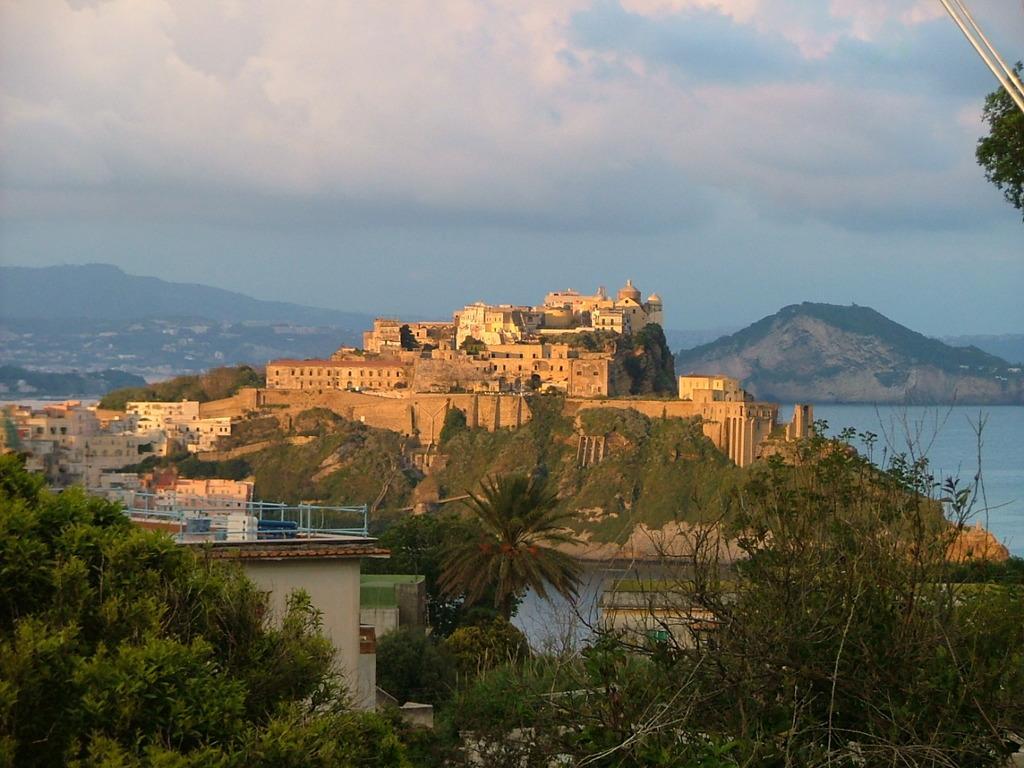Could you give a brief overview of what you see in this image? In this image I can see number of trees and number of buildings in the front. In the background I can see water, mountains, clouds and the sky. I can also see few silver colour things and a tree on the top right side of this image. 